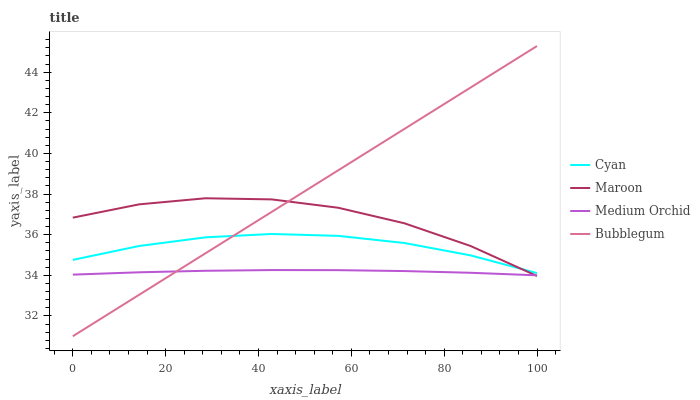Does Medium Orchid have the minimum area under the curve?
Answer yes or no. Yes. Does Bubblegum have the maximum area under the curve?
Answer yes or no. Yes. Does Bubblegum have the minimum area under the curve?
Answer yes or no. No. Does Medium Orchid have the maximum area under the curve?
Answer yes or no. No. Is Bubblegum the smoothest?
Answer yes or no. Yes. Is Maroon the roughest?
Answer yes or no. Yes. Is Medium Orchid the smoothest?
Answer yes or no. No. Is Medium Orchid the roughest?
Answer yes or no. No. Does Bubblegum have the lowest value?
Answer yes or no. Yes. Does Medium Orchid have the lowest value?
Answer yes or no. No. Does Bubblegum have the highest value?
Answer yes or no. Yes. Does Medium Orchid have the highest value?
Answer yes or no. No. Is Medium Orchid less than Cyan?
Answer yes or no. Yes. Is Cyan greater than Medium Orchid?
Answer yes or no. Yes. Does Maroon intersect Medium Orchid?
Answer yes or no. Yes. Is Maroon less than Medium Orchid?
Answer yes or no. No. Is Maroon greater than Medium Orchid?
Answer yes or no. No. Does Medium Orchid intersect Cyan?
Answer yes or no. No. 